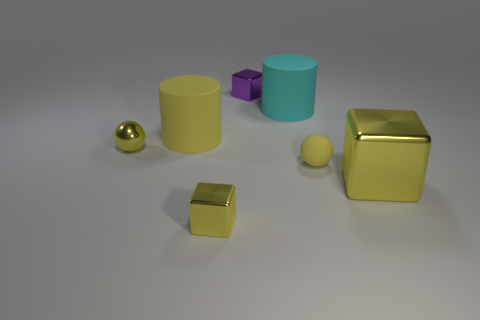There is another yellow thing that is the same shape as the big metal object; what size is it?
Your answer should be very brief. Small. Does the big block have the same color as the big matte object in front of the big cyan rubber thing?
Offer a very short reply. Yes. Is the color of the big metallic cube the same as the tiny matte ball?
Offer a very short reply. Yes. Are there fewer yellow metal spheres than small gray cylinders?
Give a very brief answer. No. What number of other objects are the same color as the rubber sphere?
Your answer should be compact. 4. What number of large blocks are there?
Your answer should be very brief. 1. Are there fewer yellow shiny blocks that are behind the big cyan object than large cyan things?
Give a very brief answer. Yes. Does the yellow ball that is on the left side of the cyan matte cylinder have the same material as the small purple object?
Make the answer very short. Yes. What shape is the small thing right of the cylinder that is on the right side of the tiny metal block that is left of the small purple block?
Give a very brief answer. Sphere. Are there any cyan rubber cylinders that have the same size as the yellow matte ball?
Your response must be concise. No. 